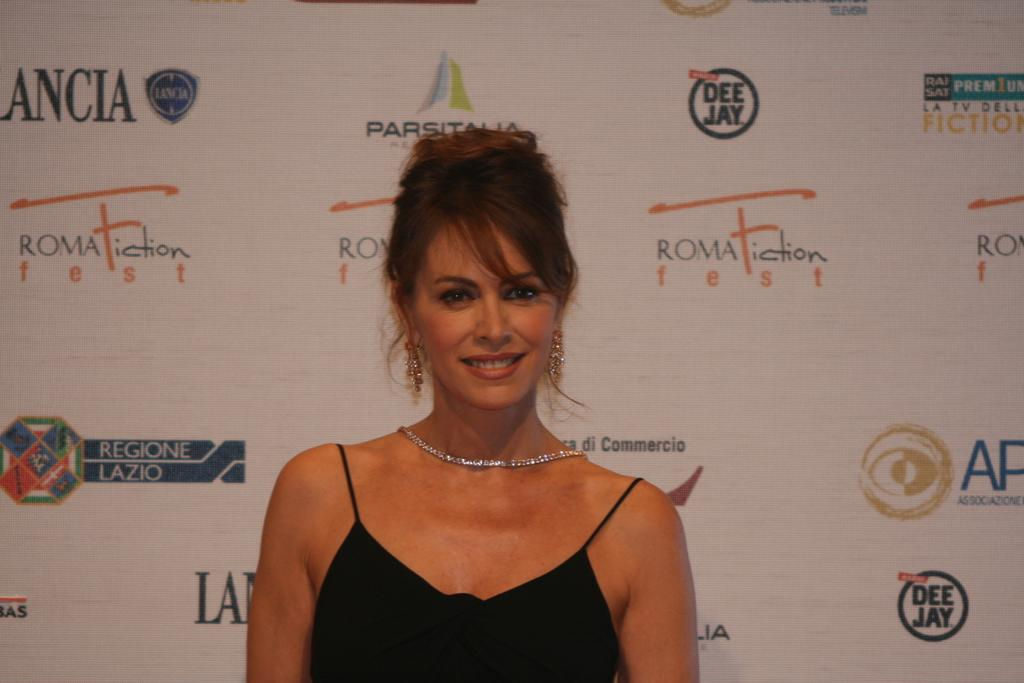Who is present in the image? There is a girl in the image. What expression does the girl have on her face? The girl has a smile on her face. What type of jewel is the girl holding in the image? There is no jewel present in the image; the girl is simply smiling. 